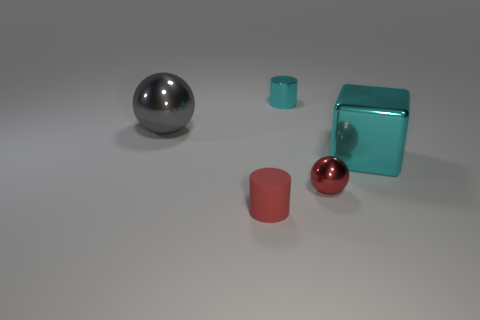Is the number of tiny metal spheres in front of the small rubber thing less than the number of small green metallic balls?
Your response must be concise. No. Is there anything else that has the same size as the cyan cylinder?
Provide a short and direct response. Yes. There is a cylinder in front of the tiny metal thing that is behind the big gray thing; what is its size?
Provide a short and direct response. Small. Are there any other things that are the same shape as the tiny cyan thing?
Provide a short and direct response. Yes. Are there fewer large brown metal cylinders than tiny red shiny spheres?
Provide a short and direct response. Yes. The small thing that is in front of the cyan metallic cylinder and on the left side of the small red shiny object is made of what material?
Your response must be concise. Rubber. Are there any big objects that are left of the cyan metallic thing that is behind the gray object?
Your answer should be compact. Yes. What number of objects are small red matte cylinders or small cyan things?
Give a very brief answer. 2. There is a small thing that is both to the left of the red ball and right of the tiny rubber object; what shape is it?
Offer a very short reply. Cylinder. Do the cylinder in front of the large cyan shiny thing and the large gray thing have the same material?
Give a very brief answer. No. 